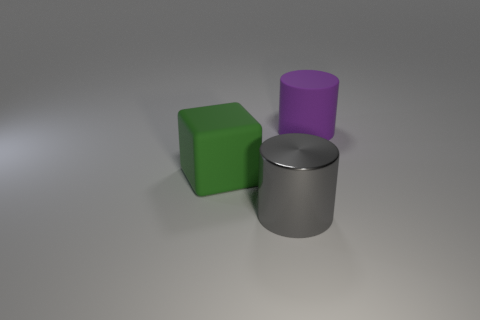Add 3 metal objects. How many objects exist? 6 Subtract all blocks. How many objects are left? 2 Add 1 large purple cylinders. How many large purple cylinders exist? 2 Subtract 0 cyan balls. How many objects are left? 3 Subtract all big purple cylinders. Subtract all large metallic cylinders. How many objects are left? 1 Add 1 large purple things. How many large purple things are left? 2 